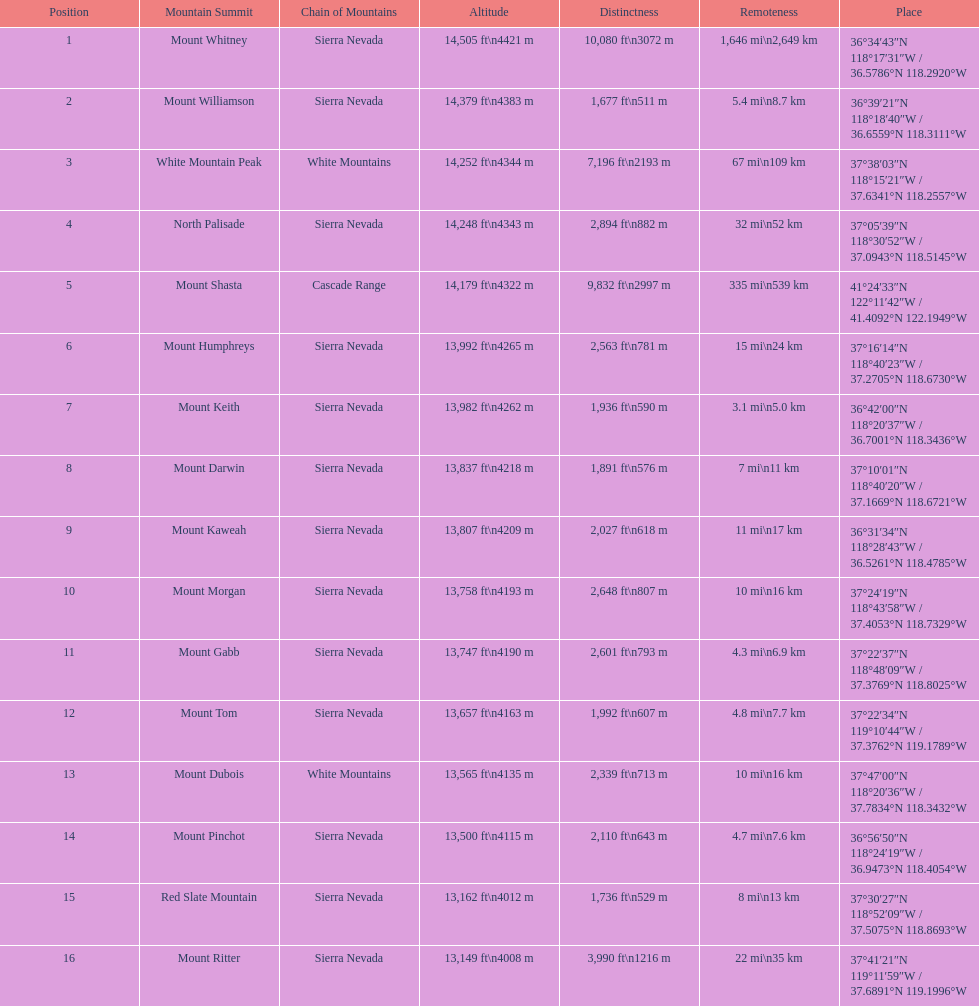What is the total elevation (in ft) of mount whitney? 14,505 ft. Would you be able to parse every entry in this table? {'header': ['Position', 'Mountain Summit', 'Chain of Mountains', 'Altitude', 'Distinctness', 'Remoteness', 'Place'], 'rows': [['1', 'Mount Whitney', 'Sierra Nevada', '14,505\xa0ft\\n4421\xa0m', '10,080\xa0ft\\n3072\xa0m', '1,646\xa0mi\\n2,649\xa0km', '36°34′43″N 118°17′31″W\ufeff / \ufeff36.5786°N 118.2920°W'], ['2', 'Mount Williamson', 'Sierra Nevada', '14,379\xa0ft\\n4383\xa0m', '1,677\xa0ft\\n511\xa0m', '5.4\xa0mi\\n8.7\xa0km', '36°39′21″N 118°18′40″W\ufeff / \ufeff36.6559°N 118.3111°W'], ['3', 'White Mountain Peak', 'White Mountains', '14,252\xa0ft\\n4344\xa0m', '7,196\xa0ft\\n2193\xa0m', '67\xa0mi\\n109\xa0km', '37°38′03″N 118°15′21″W\ufeff / \ufeff37.6341°N 118.2557°W'], ['4', 'North Palisade', 'Sierra Nevada', '14,248\xa0ft\\n4343\xa0m', '2,894\xa0ft\\n882\xa0m', '32\xa0mi\\n52\xa0km', '37°05′39″N 118°30′52″W\ufeff / \ufeff37.0943°N 118.5145°W'], ['5', 'Mount Shasta', 'Cascade Range', '14,179\xa0ft\\n4322\xa0m', '9,832\xa0ft\\n2997\xa0m', '335\xa0mi\\n539\xa0km', '41°24′33″N 122°11′42″W\ufeff / \ufeff41.4092°N 122.1949°W'], ['6', 'Mount Humphreys', 'Sierra Nevada', '13,992\xa0ft\\n4265\xa0m', '2,563\xa0ft\\n781\xa0m', '15\xa0mi\\n24\xa0km', '37°16′14″N 118°40′23″W\ufeff / \ufeff37.2705°N 118.6730°W'], ['7', 'Mount Keith', 'Sierra Nevada', '13,982\xa0ft\\n4262\xa0m', '1,936\xa0ft\\n590\xa0m', '3.1\xa0mi\\n5.0\xa0km', '36°42′00″N 118°20′37″W\ufeff / \ufeff36.7001°N 118.3436°W'], ['8', 'Mount Darwin', 'Sierra Nevada', '13,837\xa0ft\\n4218\xa0m', '1,891\xa0ft\\n576\xa0m', '7\xa0mi\\n11\xa0km', '37°10′01″N 118°40′20″W\ufeff / \ufeff37.1669°N 118.6721°W'], ['9', 'Mount Kaweah', 'Sierra Nevada', '13,807\xa0ft\\n4209\xa0m', '2,027\xa0ft\\n618\xa0m', '11\xa0mi\\n17\xa0km', '36°31′34″N 118°28′43″W\ufeff / \ufeff36.5261°N 118.4785°W'], ['10', 'Mount Morgan', 'Sierra Nevada', '13,758\xa0ft\\n4193\xa0m', '2,648\xa0ft\\n807\xa0m', '10\xa0mi\\n16\xa0km', '37°24′19″N 118°43′58″W\ufeff / \ufeff37.4053°N 118.7329°W'], ['11', 'Mount Gabb', 'Sierra Nevada', '13,747\xa0ft\\n4190\xa0m', '2,601\xa0ft\\n793\xa0m', '4.3\xa0mi\\n6.9\xa0km', '37°22′37″N 118°48′09″W\ufeff / \ufeff37.3769°N 118.8025°W'], ['12', 'Mount Tom', 'Sierra Nevada', '13,657\xa0ft\\n4163\xa0m', '1,992\xa0ft\\n607\xa0m', '4.8\xa0mi\\n7.7\xa0km', '37°22′34″N 119°10′44″W\ufeff / \ufeff37.3762°N 119.1789°W'], ['13', 'Mount Dubois', 'White Mountains', '13,565\xa0ft\\n4135\xa0m', '2,339\xa0ft\\n713\xa0m', '10\xa0mi\\n16\xa0km', '37°47′00″N 118°20′36″W\ufeff / \ufeff37.7834°N 118.3432°W'], ['14', 'Mount Pinchot', 'Sierra Nevada', '13,500\xa0ft\\n4115\xa0m', '2,110\xa0ft\\n643\xa0m', '4.7\xa0mi\\n7.6\xa0km', '36°56′50″N 118°24′19″W\ufeff / \ufeff36.9473°N 118.4054°W'], ['15', 'Red Slate Mountain', 'Sierra Nevada', '13,162\xa0ft\\n4012\xa0m', '1,736\xa0ft\\n529\xa0m', '8\xa0mi\\n13\xa0km', '37°30′27″N 118°52′09″W\ufeff / \ufeff37.5075°N 118.8693°W'], ['16', 'Mount Ritter', 'Sierra Nevada', '13,149\xa0ft\\n4008\xa0m', '3,990\xa0ft\\n1216\xa0m', '22\xa0mi\\n35\xa0km', '37°41′21″N 119°11′59″W\ufeff / \ufeff37.6891°N 119.1996°W']]} 